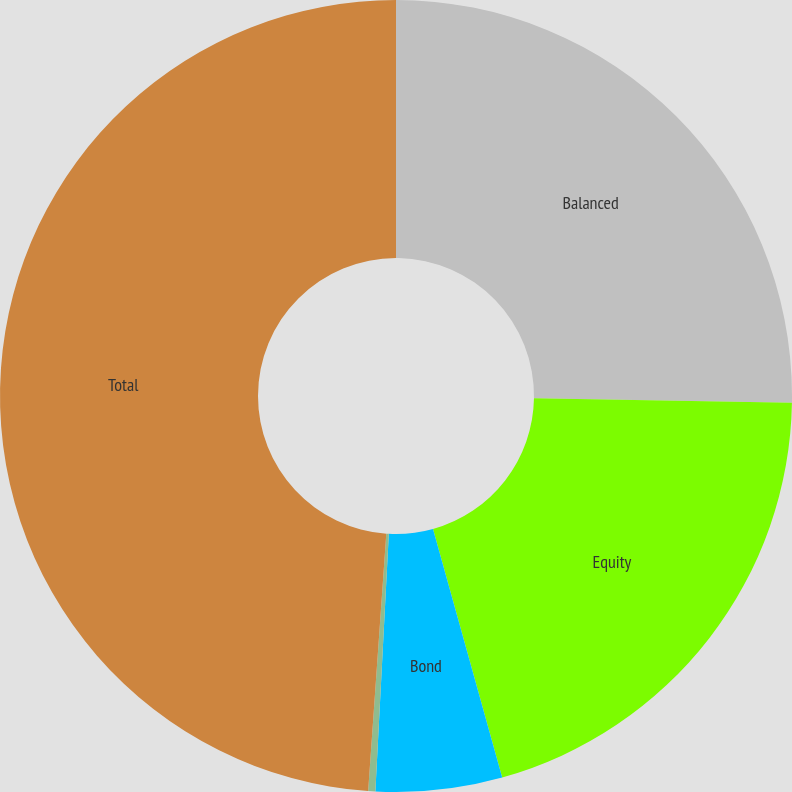<chart> <loc_0><loc_0><loc_500><loc_500><pie_chart><fcel>Balanced<fcel>Equity<fcel>Bond<fcel>Money Market<fcel>Total<nl><fcel>25.27%<fcel>20.41%<fcel>5.15%<fcel>0.29%<fcel>48.88%<nl></chart> 